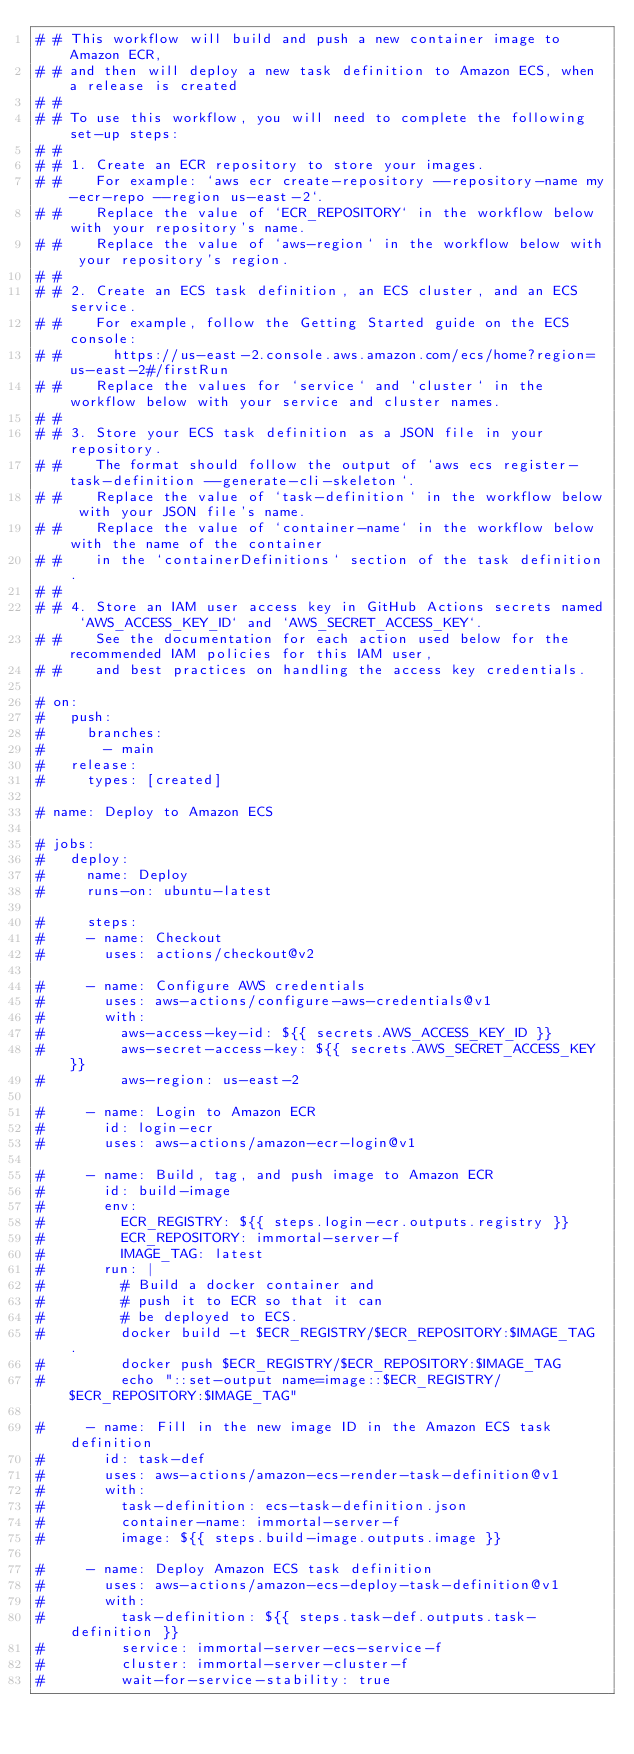<code> <loc_0><loc_0><loc_500><loc_500><_YAML_># # This workflow will build and push a new container image to Amazon ECR,
# # and then will deploy a new task definition to Amazon ECS, when a release is created
# #
# # To use this workflow, you will need to complete the following set-up steps:
# #
# # 1. Create an ECR repository to store your images.
# #    For example: `aws ecr create-repository --repository-name my-ecr-repo --region us-east-2`.
# #    Replace the value of `ECR_REPOSITORY` in the workflow below with your repository's name.
# #    Replace the value of `aws-region` in the workflow below with your repository's region.
# #
# # 2. Create an ECS task definition, an ECS cluster, and an ECS service.
# #    For example, follow the Getting Started guide on the ECS console:
# #      https://us-east-2.console.aws.amazon.com/ecs/home?region=us-east-2#/firstRun
# #    Replace the values for `service` and `cluster` in the workflow below with your service and cluster names.
# #
# # 3. Store your ECS task definition as a JSON file in your repository.
# #    The format should follow the output of `aws ecs register-task-definition --generate-cli-skeleton`.
# #    Replace the value of `task-definition` in the workflow below with your JSON file's name.
# #    Replace the value of `container-name` in the workflow below with the name of the container
# #    in the `containerDefinitions` section of the task definition.
# #
# # 4. Store an IAM user access key in GitHub Actions secrets named `AWS_ACCESS_KEY_ID` and `AWS_SECRET_ACCESS_KEY`.
# #    See the documentation for each action used below for the recommended IAM policies for this IAM user,
# #    and best practices on handling the access key credentials.

# on:
#   push:
#     branches: 
#       - main
#   release:
#     types: [created]

# name: Deploy to Amazon ECS

# jobs:
#   deploy:
#     name: Deploy
#     runs-on: ubuntu-latest

#     steps:
#     - name: Checkout
#       uses: actions/checkout@v2

#     - name: Configure AWS credentials
#       uses: aws-actions/configure-aws-credentials@v1
#       with:
#         aws-access-key-id: ${{ secrets.AWS_ACCESS_KEY_ID }}
#         aws-secret-access-key: ${{ secrets.AWS_SECRET_ACCESS_KEY }}
#         aws-region: us-east-2

#     - name: Login to Amazon ECR
#       id: login-ecr
#       uses: aws-actions/amazon-ecr-login@v1

#     - name: Build, tag, and push image to Amazon ECR
#       id: build-image
#       env:
#         ECR_REGISTRY: ${{ steps.login-ecr.outputs.registry }}
#         ECR_REPOSITORY: immortal-server-f
#         IMAGE_TAG: latest
#       run: |
#         # Build a docker container and
#         # push it to ECR so that it can
#         # be deployed to ECS.
#         docker build -t $ECR_REGISTRY/$ECR_REPOSITORY:$IMAGE_TAG .
#         docker push $ECR_REGISTRY/$ECR_REPOSITORY:$IMAGE_TAG
#         echo "::set-output name=image::$ECR_REGISTRY/$ECR_REPOSITORY:$IMAGE_TAG"

#     - name: Fill in the new image ID in the Amazon ECS task definition
#       id: task-def
#       uses: aws-actions/amazon-ecs-render-task-definition@v1
#       with:
#         task-definition: ecs-task-definition.json
#         container-name: immortal-server-f
#         image: ${{ steps.build-image.outputs.image }}

#     - name: Deploy Amazon ECS task definition
#       uses: aws-actions/amazon-ecs-deploy-task-definition@v1
#       with:
#         task-definition: ${{ steps.task-def.outputs.task-definition }}
#         service: immortal-server-ecs-service-f
#         cluster: immortal-server-cluster-f
#         wait-for-service-stability: true
</code> 